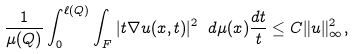<formula> <loc_0><loc_0><loc_500><loc_500>\frac { 1 } { \mu ( Q ) } \int _ { 0 } ^ { \ell ( Q ) } \int _ { F } | t \nabla u ( x , t ) | ^ { 2 } \ d \mu ( x ) \frac { d t } { t } \leq C \| u \| _ { \infty } ^ { 2 } ,</formula> 